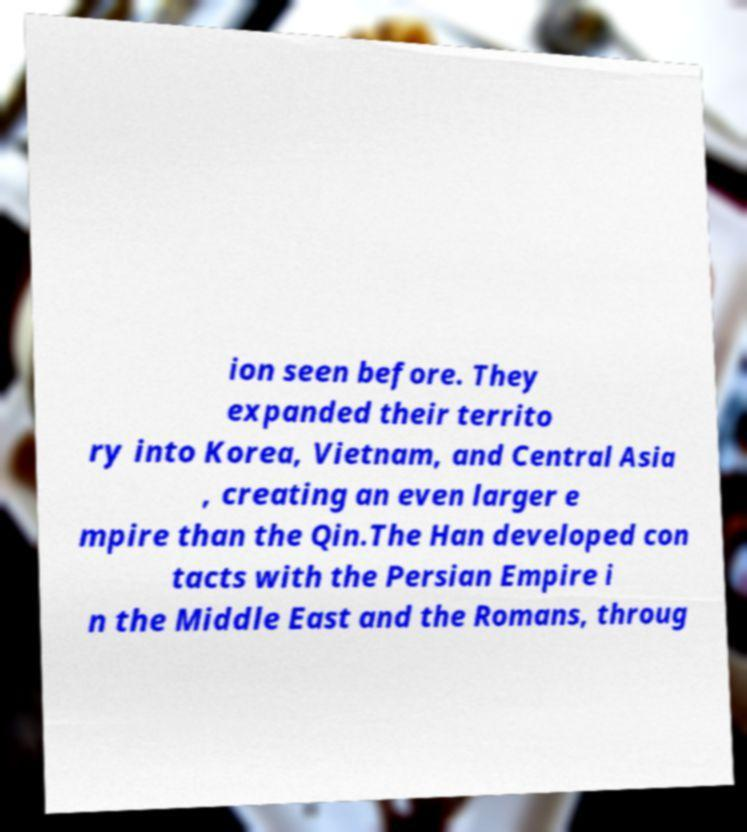I need the written content from this picture converted into text. Can you do that? ion seen before. They expanded their territo ry into Korea, Vietnam, and Central Asia , creating an even larger e mpire than the Qin.The Han developed con tacts with the Persian Empire i n the Middle East and the Romans, throug 